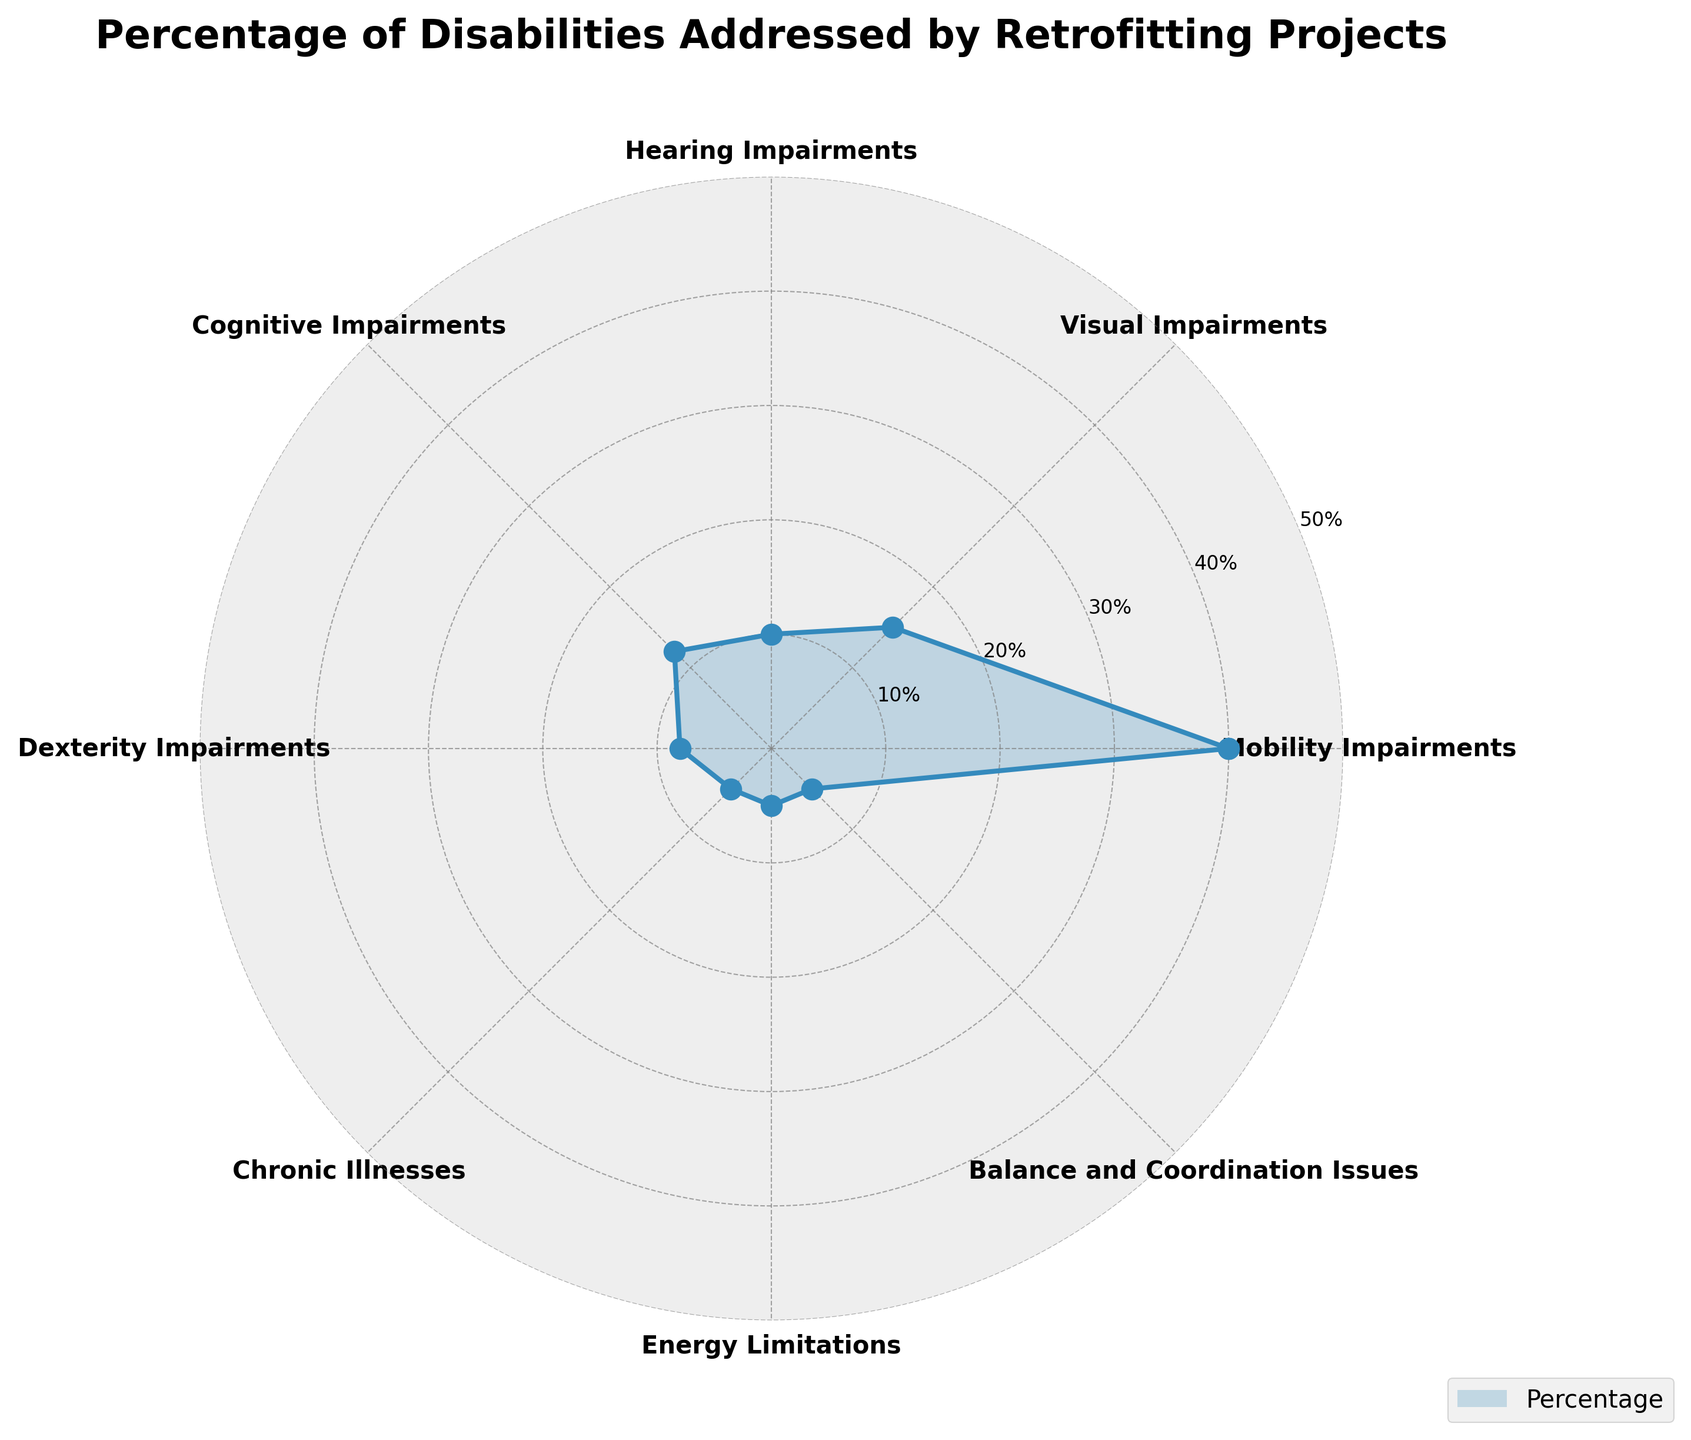Which disability category has the highest percentage addressed by retrofitting projects? By observing the chart, the largest section is associated with Mobility Impairments. Therefore, the percentage addressed by retrofitting projects for this category is the highest.
Answer: Mobility Impairments What is the title of the chart? The title is written at the top of the chart.
Answer: Percentage of Disabilities Addressed by Retrofitting Projects How many disability categories are shown in the chart? Count the number of labeled sections around the polar area chart. There are 8 categories labeled.
Answer: 8 Which disability categories have the same percentage addressed by retrofitting projects? By examining the chart, we can see three categories (Chronic Illnesses, Energy Limitations, and Balance and Coordination Issues) with equal sections representing the same percentage.
Answer: Chronic Illnesses, Energy Limitations, Balance and Coordination Issues What is the angle spacing between each disability category? There are 8 categories, represented by equal spacing around a 360-degree circle. Calculate the angle as 360 / 8.
Answer: 45 degrees What percentage is addressed by retrofitting projects for hearing impairments? Identify the section labeled Hearing Impairments and read the corresponding percentage value from it.
Answer: 10% Which disability category is addressed less than Visual Impairments but more than Dexterity Impairments? By comparing the sections, the category between these two percentages (15% and 8%) is Cognitive Impairments.
Answer: Cognitive Impairments What is the combined percentage addressed for Mobility and Visual Impairments? Add the percentages of Mobility Impairments and Visual Impairments (40% + 15%).
Answer: 55% Which disability categories have less than 10% each addressed by retrofitting projects? Identify the sections with percentages below 10%, which are Dexterity Impairments, Chronic Illnesses, Energy Limitations, and Balance and Coordination Issues.
Answer: Dexterity Impairments, Chronic Illnesses, Energy Limitations, Balance and Coordination Issues What is the average percentage addressed for all disability categories? Add up all the percentages and divide by the number of categories: (40+15+10+12+8+5+5+5)/8.
Answer: 12.5% 